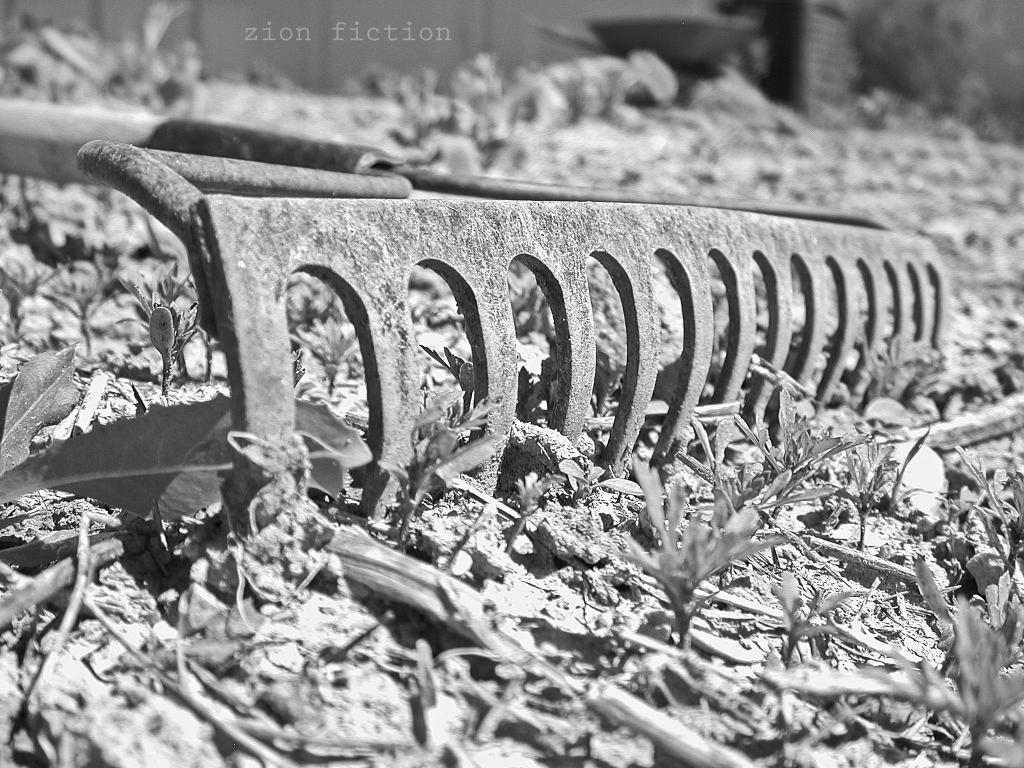What object can be seen on the floor in the image? There is an iron rod on the floor in the image. What else is on the floor in the image? There are leaves on the floor in the image. What type of needle is used to stop the iron rod in the image? There is no needle present in the image, and the iron rod is not moving, so there is no need to stop it. 